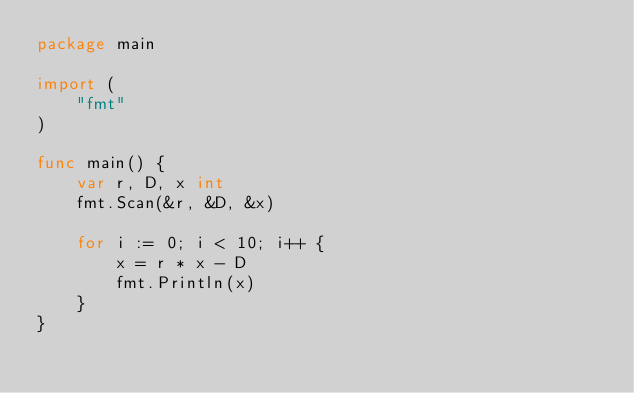<code> <loc_0><loc_0><loc_500><loc_500><_Go_>package main

import (
	"fmt"
)

func main() {
	var r, D, x int
	fmt.Scan(&r, &D, &x)

	for i := 0; i < 10; i++ {
		x = r * x - D
		fmt.Println(x)
	}
}</code> 